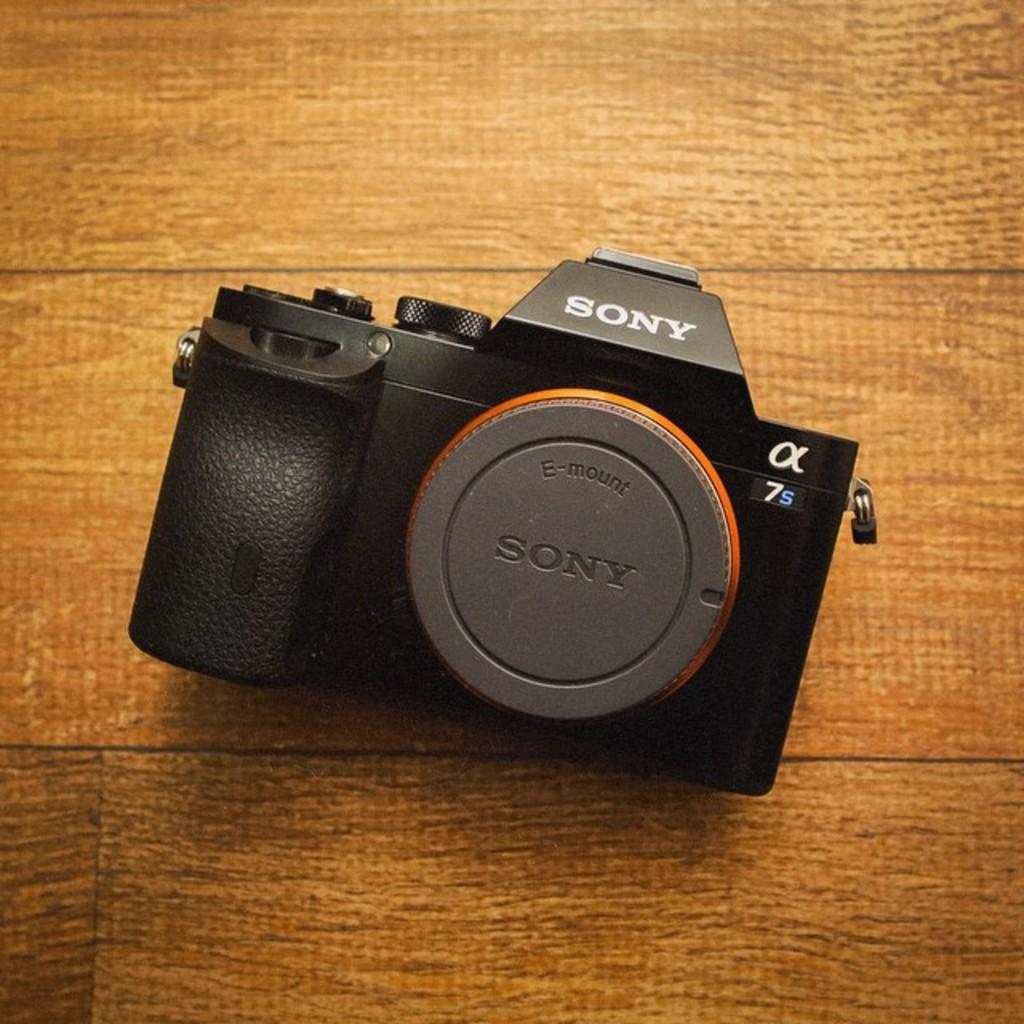What brand is the camera?
Your answer should be very brief. Sony. 